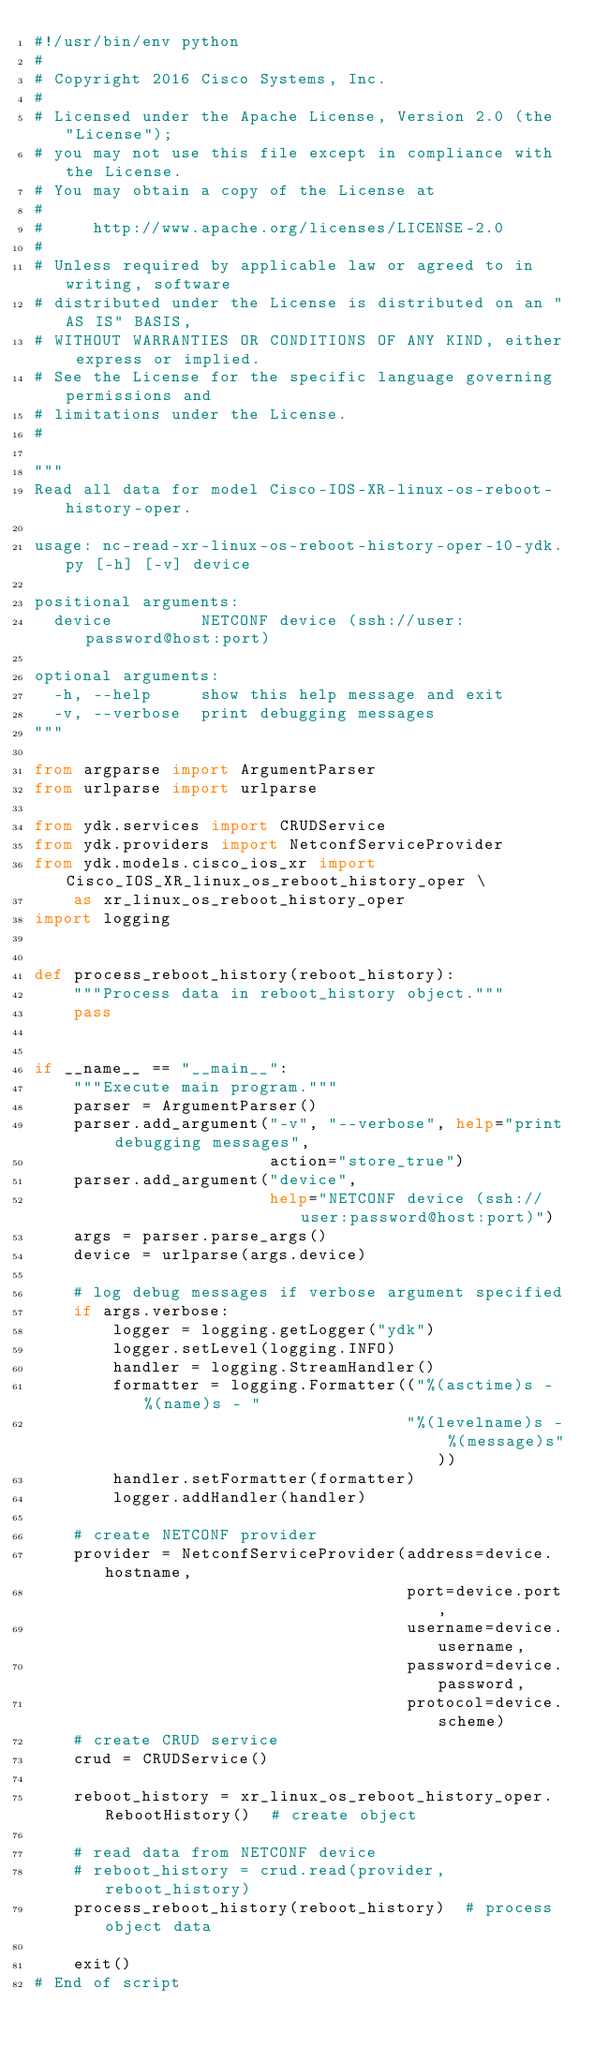<code> <loc_0><loc_0><loc_500><loc_500><_Python_>#!/usr/bin/env python
#
# Copyright 2016 Cisco Systems, Inc.
#
# Licensed under the Apache License, Version 2.0 (the "License");
# you may not use this file except in compliance with the License.
# You may obtain a copy of the License at
#
#     http://www.apache.org/licenses/LICENSE-2.0
#
# Unless required by applicable law or agreed to in writing, software
# distributed under the License is distributed on an "AS IS" BASIS,
# WITHOUT WARRANTIES OR CONDITIONS OF ANY KIND, either express or implied.
# See the License for the specific language governing permissions and
# limitations under the License.
#

"""
Read all data for model Cisco-IOS-XR-linux-os-reboot-history-oper.

usage: nc-read-xr-linux-os-reboot-history-oper-10-ydk.py [-h] [-v] device

positional arguments:
  device         NETCONF device (ssh://user:password@host:port)

optional arguments:
  -h, --help     show this help message and exit
  -v, --verbose  print debugging messages
"""

from argparse import ArgumentParser
from urlparse import urlparse

from ydk.services import CRUDService
from ydk.providers import NetconfServiceProvider
from ydk.models.cisco_ios_xr import Cisco_IOS_XR_linux_os_reboot_history_oper \
    as xr_linux_os_reboot_history_oper
import logging


def process_reboot_history(reboot_history):
    """Process data in reboot_history object."""
    pass


if __name__ == "__main__":
    """Execute main program."""
    parser = ArgumentParser()
    parser.add_argument("-v", "--verbose", help="print debugging messages",
                        action="store_true")
    parser.add_argument("device",
                        help="NETCONF device (ssh://user:password@host:port)")
    args = parser.parse_args()
    device = urlparse(args.device)

    # log debug messages if verbose argument specified
    if args.verbose:
        logger = logging.getLogger("ydk")
        logger.setLevel(logging.INFO)
        handler = logging.StreamHandler()
        formatter = logging.Formatter(("%(asctime)s - %(name)s - "
                                      "%(levelname)s - %(message)s"))
        handler.setFormatter(formatter)
        logger.addHandler(handler)

    # create NETCONF provider
    provider = NetconfServiceProvider(address=device.hostname,
                                      port=device.port,
                                      username=device.username,
                                      password=device.password,
                                      protocol=device.scheme)
    # create CRUD service
    crud = CRUDService()

    reboot_history = xr_linux_os_reboot_history_oper.RebootHistory()  # create object

    # read data from NETCONF device
    # reboot_history = crud.read(provider, reboot_history)
    process_reboot_history(reboot_history)  # process object data

    exit()
# End of script
</code> 